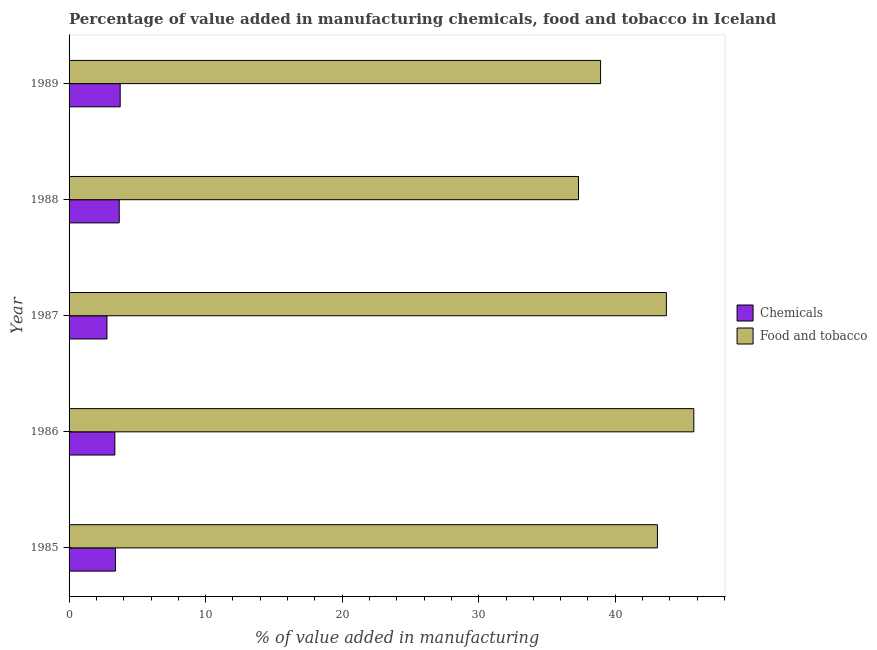How many groups of bars are there?
Give a very brief answer. 5. Are the number of bars on each tick of the Y-axis equal?
Your answer should be very brief. Yes. How many bars are there on the 4th tick from the top?
Your answer should be compact. 2. How many bars are there on the 1st tick from the bottom?
Your answer should be compact. 2. What is the label of the 4th group of bars from the top?
Your response must be concise. 1986. In how many cases, is the number of bars for a given year not equal to the number of legend labels?
Give a very brief answer. 0. What is the value added by manufacturing food and tobacco in 1985?
Your answer should be compact. 43.09. Across all years, what is the maximum value added by manufacturing food and tobacco?
Offer a very short reply. 45.76. Across all years, what is the minimum value added by  manufacturing chemicals?
Your answer should be very brief. 2.78. In which year was the value added by  manufacturing chemicals maximum?
Keep it short and to the point. 1989. In which year was the value added by  manufacturing chemicals minimum?
Offer a very short reply. 1987. What is the total value added by  manufacturing chemicals in the graph?
Provide a short and direct response. 16.94. What is the difference between the value added by  manufacturing chemicals in 1985 and that in 1986?
Provide a short and direct response. 0.04. What is the difference between the value added by  manufacturing chemicals in 1985 and the value added by manufacturing food and tobacco in 1987?
Keep it short and to the point. -40.35. What is the average value added by  manufacturing chemicals per year?
Your response must be concise. 3.39. In the year 1987, what is the difference between the value added by manufacturing food and tobacco and value added by  manufacturing chemicals?
Keep it short and to the point. 40.97. In how many years, is the value added by manufacturing food and tobacco greater than 22 %?
Offer a very short reply. 5. What is the ratio of the value added by  manufacturing chemicals in 1986 to that in 1987?
Provide a short and direct response. 1.21. Is the value added by  manufacturing chemicals in 1985 less than that in 1987?
Offer a terse response. No. What is the difference between the highest and the second highest value added by manufacturing food and tobacco?
Give a very brief answer. 2.01. What is the difference between the highest and the lowest value added by manufacturing food and tobacco?
Your answer should be compact. 8.45. Is the sum of the value added by manufacturing food and tobacco in 1986 and 1988 greater than the maximum value added by  manufacturing chemicals across all years?
Provide a short and direct response. Yes. What does the 2nd bar from the top in 1986 represents?
Your response must be concise. Chemicals. What does the 1st bar from the bottom in 1987 represents?
Give a very brief answer. Chemicals. How many bars are there?
Make the answer very short. 10. Are all the bars in the graph horizontal?
Make the answer very short. Yes. How many years are there in the graph?
Your answer should be compact. 5. Are the values on the major ticks of X-axis written in scientific E-notation?
Offer a very short reply. No. Does the graph contain any zero values?
Offer a terse response. No. Does the graph contain grids?
Give a very brief answer. No. Where does the legend appear in the graph?
Your answer should be very brief. Center right. How are the legend labels stacked?
Keep it short and to the point. Vertical. What is the title of the graph?
Offer a terse response. Percentage of value added in manufacturing chemicals, food and tobacco in Iceland. What is the label or title of the X-axis?
Make the answer very short. % of value added in manufacturing. What is the label or title of the Y-axis?
Give a very brief answer. Year. What is the % of value added in manufacturing of Chemicals in 1985?
Your answer should be compact. 3.4. What is the % of value added in manufacturing in Food and tobacco in 1985?
Offer a terse response. 43.09. What is the % of value added in manufacturing in Chemicals in 1986?
Offer a terse response. 3.35. What is the % of value added in manufacturing of Food and tobacco in 1986?
Make the answer very short. 45.76. What is the % of value added in manufacturing of Chemicals in 1987?
Provide a short and direct response. 2.78. What is the % of value added in manufacturing in Food and tobacco in 1987?
Provide a short and direct response. 43.75. What is the % of value added in manufacturing of Chemicals in 1988?
Provide a short and direct response. 3.67. What is the % of value added in manufacturing in Food and tobacco in 1988?
Give a very brief answer. 37.31. What is the % of value added in manufacturing in Chemicals in 1989?
Your response must be concise. 3.74. What is the % of value added in manufacturing of Food and tobacco in 1989?
Offer a terse response. 38.93. Across all years, what is the maximum % of value added in manufacturing of Chemicals?
Provide a short and direct response. 3.74. Across all years, what is the maximum % of value added in manufacturing of Food and tobacco?
Ensure brevity in your answer.  45.76. Across all years, what is the minimum % of value added in manufacturing in Chemicals?
Provide a succinct answer. 2.78. Across all years, what is the minimum % of value added in manufacturing of Food and tobacco?
Make the answer very short. 37.31. What is the total % of value added in manufacturing in Chemicals in the graph?
Your response must be concise. 16.94. What is the total % of value added in manufacturing in Food and tobacco in the graph?
Your response must be concise. 208.84. What is the difference between the % of value added in manufacturing of Chemicals in 1985 and that in 1986?
Make the answer very short. 0.04. What is the difference between the % of value added in manufacturing of Food and tobacco in 1985 and that in 1986?
Your response must be concise. -2.66. What is the difference between the % of value added in manufacturing in Chemicals in 1985 and that in 1987?
Offer a terse response. 0.62. What is the difference between the % of value added in manufacturing of Food and tobacco in 1985 and that in 1987?
Give a very brief answer. -0.65. What is the difference between the % of value added in manufacturing of Chemicals in 1985 and that in 1988?
Your response must be concise. -0.28. What is the difference between the % of value added in manufacturing in Food and tobacco in 1985 and that in 1988?
Give a very brief answer. 5.78. What is the difference between the % of value added in manufacturing in Chemicals in 1985 and that in 1989?
Your answer should be compact. -0.35. What is the difference between the % of value added in manufacturing of Food and tobacco in 1985 and that in 1989?
Your answer should be compact. 4.17. What is the difference between the % of value added in manufacturing in Chemicals in 1986 and that in 1987?
Your answer should be very brief. 0.58. What is the difference between the % of value added in manufacturing in Food and tobacco in 1986 and that in 1987?
Provide a short and direct response. 2.01. What is the difference between the % of value added in manufacturing of Chemicals in 1986 and that in 1988?
Ensure brevity in your answer.  -0.32. What is the difference between the % of value added in manufacturing in Food and tobacco in 1986 and that in 1988?
Make the answer very short. 8.45. What is the difference between the % of value added in manufacturing in Chemicals in 1986 and that in 1989?
Give a very brief answer. -0.39. What is the difference between the % of value added in manufacturing in Food and tobacco in 1986 and that in 1989?
Make the answer very short. 6.83. What is the difference between the % of value added in manufacturing in Chemicals in 1987 and that in 1988?
Your answer should be compact. -0.9. What is the difference between the % of value added in manufacturing of Food and tobacco in 1987 and that in 1988?
Offer a terse response. 6.43. What is the difference between the % of value added in manufacturing of Chemicals in 1987 and that in 1989?
Offer a terse response. -0.97. What is the difference between the % of value added in manufacturing of Food and tobacco in 1987 and that in 1989?
Provide a short and direct response. 4.82. What is the difference between the % of value added in manufacturing of Chemicals in 1988 and that in 1989?
Provide a short and direct response. -0.07. What is the difference between the % of value added in manufacturing of Food and tobacco in 1988 and that in 1989?
Provide a succinct answer. -1.62. What is the difference between the % of value added in manufacturing of Chemicals in 1985 and the % of value added in manufacturing of Food and tobacco in 1986?
Your response must be concise. -42.36. What is the difference between the % of value added in manufacturing of Chemicals in 1985 and the % of value added in manufacturing of Food and tobacco in 1987?
Offer a terse response. -40.35. What is the difference between the % of value added in manufacturing in Chemicals in 1985 and the % of value added in manufacturing in Food and tobacco in 1988?
Ensure brevity in your answer.  -33.92. What is the difference between the % of value added in manufacturing in Chemicals in 1985 and the % of value added in manufacturing in Food and tobacco in 1989?
Give a very brief answer. -35.53. What is the difference between the % of value added in manufacturing of Chemicals in 1986 and the % of value added in manufacturing of Food and tobacco in 1987?
Offer a very short reply. -40.39. What is the difference between the % of value added in manufacturing in Chemicals in 1986 and the % of value added in manufacturing in Food and tobacco in 1988?
Keep it short and to the point. -33.96. What is the difference between the % of value added in manufacturing of Chemicals in 1986 and the % of value added in manufacturing of Food and tobacco in 1989?
Keep it short and to the point. -35.57. What is the difference between the % of value added in manufacturing in Chemicals in 1987 and the % of value added in manufacturing in Food and tobacco in 1988?
Make the answer very short. -34.54. What is the difference between the % of value added in manufacturing of Chemicals in 1987 and the % of value added in manufacturing of Food and tobacco in 1989?
Give a very brief answer. -36.15. What is the difference between the % of value added in manufacturing in Chemicals in 1988 and the % of value added in manufacturing in Food and tobacco in 1989?
Ensure brevity in your answer.  -35.25. What is the average % of value added in manufacturing of Chemicals per year?
Give a very brief answer. 3.39. What is the average % of value added in manufacturing in Food and tobacco per year?
Give a very brief answer. 41.77. In the year 1985, what is the difference between the % of value added in manufacturing of Chemicals and % of value added in manufacturing of Food and tobacco?
Offer a terse response. -39.7. In the year 1986, what is the difference between the % of value added in manufacturing in Chemicals and % of value added in manufacturing in Food and tobacco?
Provide a succinct answer. -42.4. In the year 1987, what is the difference between the % of value added in manufacturing of Chemicals and % of value added in manufacturing of Food and tobacco?
Offer a very short reply. -40.97. In the year 1988, what is the difference between the % of value added in manufacturing in Chemicals and % of value added in manufacturing in Food and tobacco?
Your answer should be compact. -33.64. In the year 1989, what is the difference between the % of value added in manufacturing of Chemicals and % of value added in manufacturing of Food and tobacco?
Offer a very short reply. -35.18. What is the ratio of the % of value added in manufacturing of Chemicals in 1985 to that in 1986?
Your answer should be compact. 1.01. What is the ratio of the % of value added in manufacturing in Food and tobacco in 1985 to that in 1986?
Offer a terse response. 0.94. What is the ratio of the % of value added in manufacturing in Chemicals in 1985 to that in 1987?
Provide a succinct answer. 1.22. What is the ratio of the % of value added in manufacturing of Food and tobacco in 1985 to that in 1987?
Provide a short and direct response. 0.99. What is the ratio of the % of value added in manufacturing in Chemicals in 1985 to that in 1988?
Your answer should be very brief. 0.92. What is the ratio of the % of value added in manufacturing of Food and tobacco in 1985 to that in 1988?
Your answer should be compact. 1.16. What is the ratio of the % of value added in manufacturing of Chemicals in 1985 to that in 1989?
Make the answer very short. 0.91. What is the ratio of the % of value added in manufacturing of Food and tobacco in 1985 to that in 1989?
Your answer should be very brief. 1.11. What is the ratio of the % of value added in manufacturing in Chemicals in 1986 to that in 1987?
Provide a succinct answer. 1.21. What is the ratio of the % of value added in manufacturing of Food and tobacco in 1986 to that in 1987?
Offer a terse response. 1.05. What is the ratio of the % of value added in manufacturing of Chemicals in 1986 to that in 1988?
Your response must be concise. 0.91. What is the ratio of the % of value added in manufacturing of Food and tobacco in 1986 to that in 1988?
Provide a short and direct response. 1.23. What is the ratio of the % of value added in manufacturing of Chemicals in 1986 to that in 1989?
Offer a terse response. 0.9. What is the ratio of the % of value added in manufacturing of Food and tobacco in 1986 to that in 1989?
Ensure brevity in your answer.  1.18. What is the ratio of the % of value added in manufacturing of Chemicals in 1987 to that in 1988?
Your answer should be very brief. 0.76. What is the ratio of the % of value added in manufacturing of Food and tobacco in 1987 to that in 1988?
Your answer should be compact. 1.17. What is the ratio of the % of value added in manufacturing of Chemicals in 1987 to that in 1989?
Your answer should be compact. 0.74. What is the ratio of the % of value added in manufacturing in Food and tobacco in 1987 to that in 1989?
Ensure brevity in your answer.  1.12. What is the ratio of the % of value added in manufacturing of Chemicals in 1988 to that in 1989?
Provide a short and direct response. 0.98. What is the ratio of the % of value added in manufacturing of Food and tobacco in 1988 to that in 1989?
Your answer should be very brief. 0.96. What is the difference between the highest and the second highest % of value added in manufacturing of Chemicals?
Your response must be concise. 0.07. What is the difference between the highest and the second highest % of value added in manufacturing in Food and tobacco?
Make the answer very short. 2.01. What is the difference between the highest and the lowest % of value added in manufacturing of Chemicals?
Your answer should be very brief. 0.97. What is the difference between the highest and the lowest % of value added in manufacturing of Food and tobacco?
Your response must be concise. 8.45. 